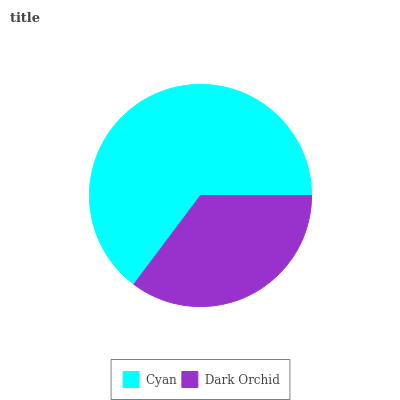Is Dark Orchid the minimum?
Answer yes or no. Yes. Is Cyan the maximum?
Answer yes or no. Yes. Is Dark Orchid the maximum?
Answer yes or no. No. Is Cyan greater than Dark Orchid?
Answer yes or no. Yes. Is Dark Orchid less than Cyan?
Answer yes or no. Yes. Is Dark Orchid greater than Cyan?
Answer yes or no. No. Is Cyan less than Dark Orchid?
Answer yes or no. No. Is Cyan the high median?
Answer yes or no. Yes. Is Dark Orchid the low median?
Answer yes or no. Yes. Is Dark Orchid the high median?
Answer yes or no. No. Is Cyan the low median?
Answer yes or no. No. 